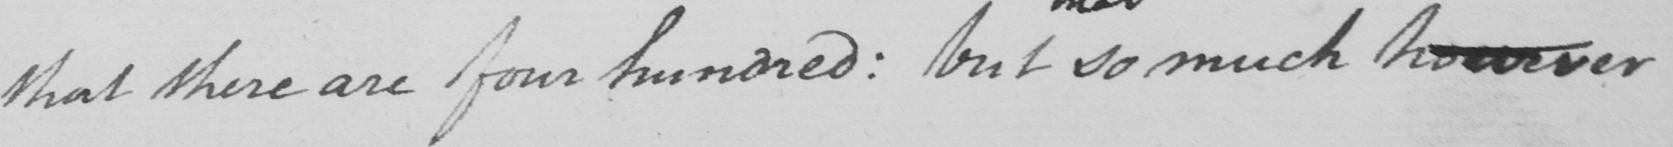Can you read and transcribe this handwriting? that there are four hundred :  but so much however 